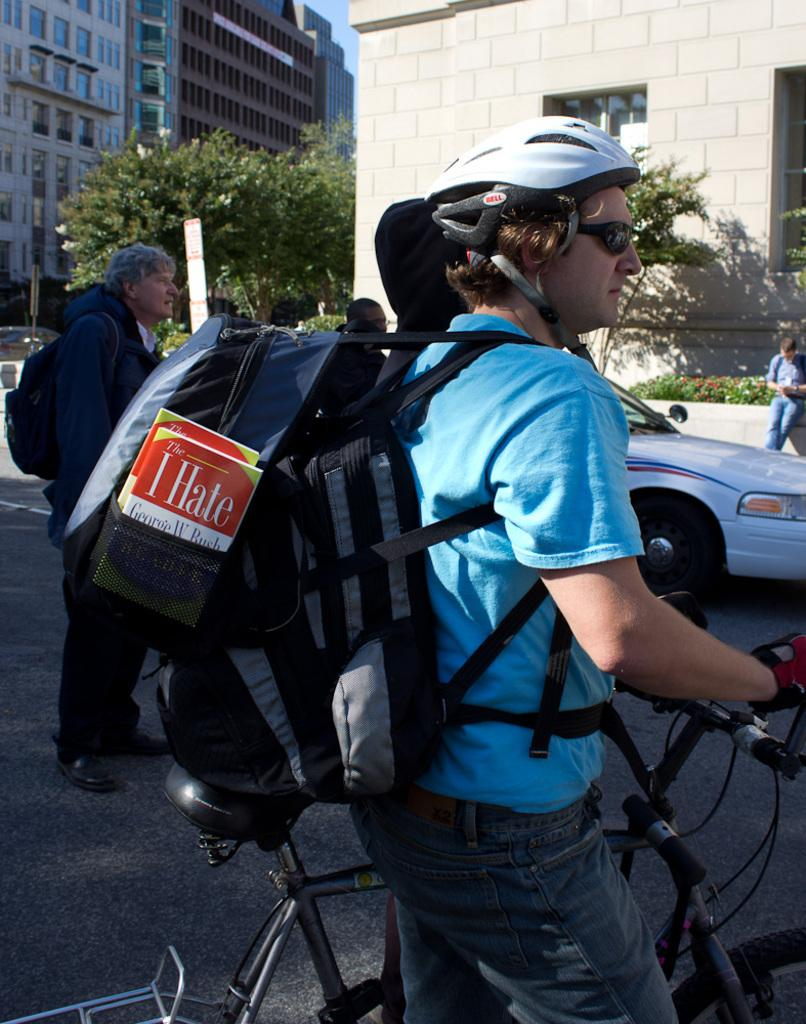<image>
Present a compact description of the photo's key features. The bike rider has a book in his backpack that says I Hate George W. Bush. 